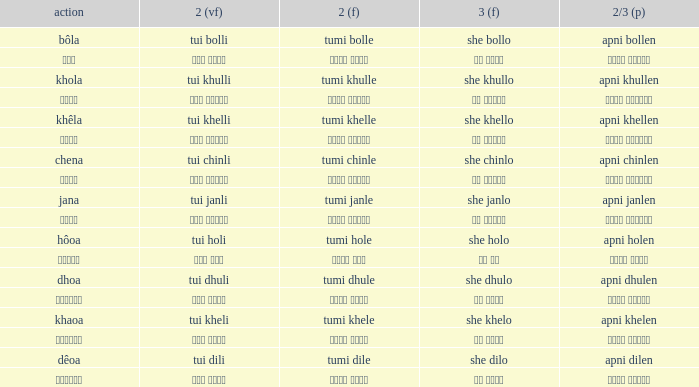What is the verb for Khola? She khullo. 